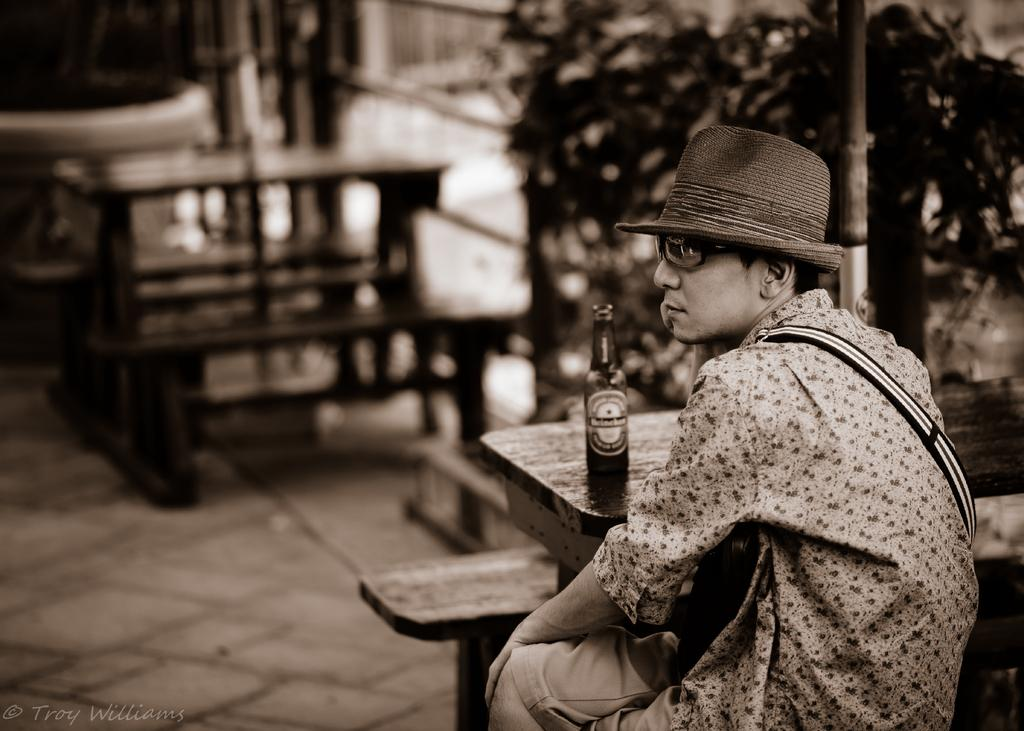What type of vegetation can be seen in the image? There are trees in the image. What type of seating is available in the image? There are benches in the image. What is the man in the image doing? The man is sitting in the image. What type of furniture is present in the image? There is a table in the image. What object is on the table in the image? There is a bottle on the table in the image. What sound can be heard coming from the squirrel in the image? There is no squirrel present in the image, so no sound can be heard from it. What additional detail can be observed about the man's clothing in the image? The provided facts do not mention any details about the man's clothing, so we cannot answer this question definitively. 